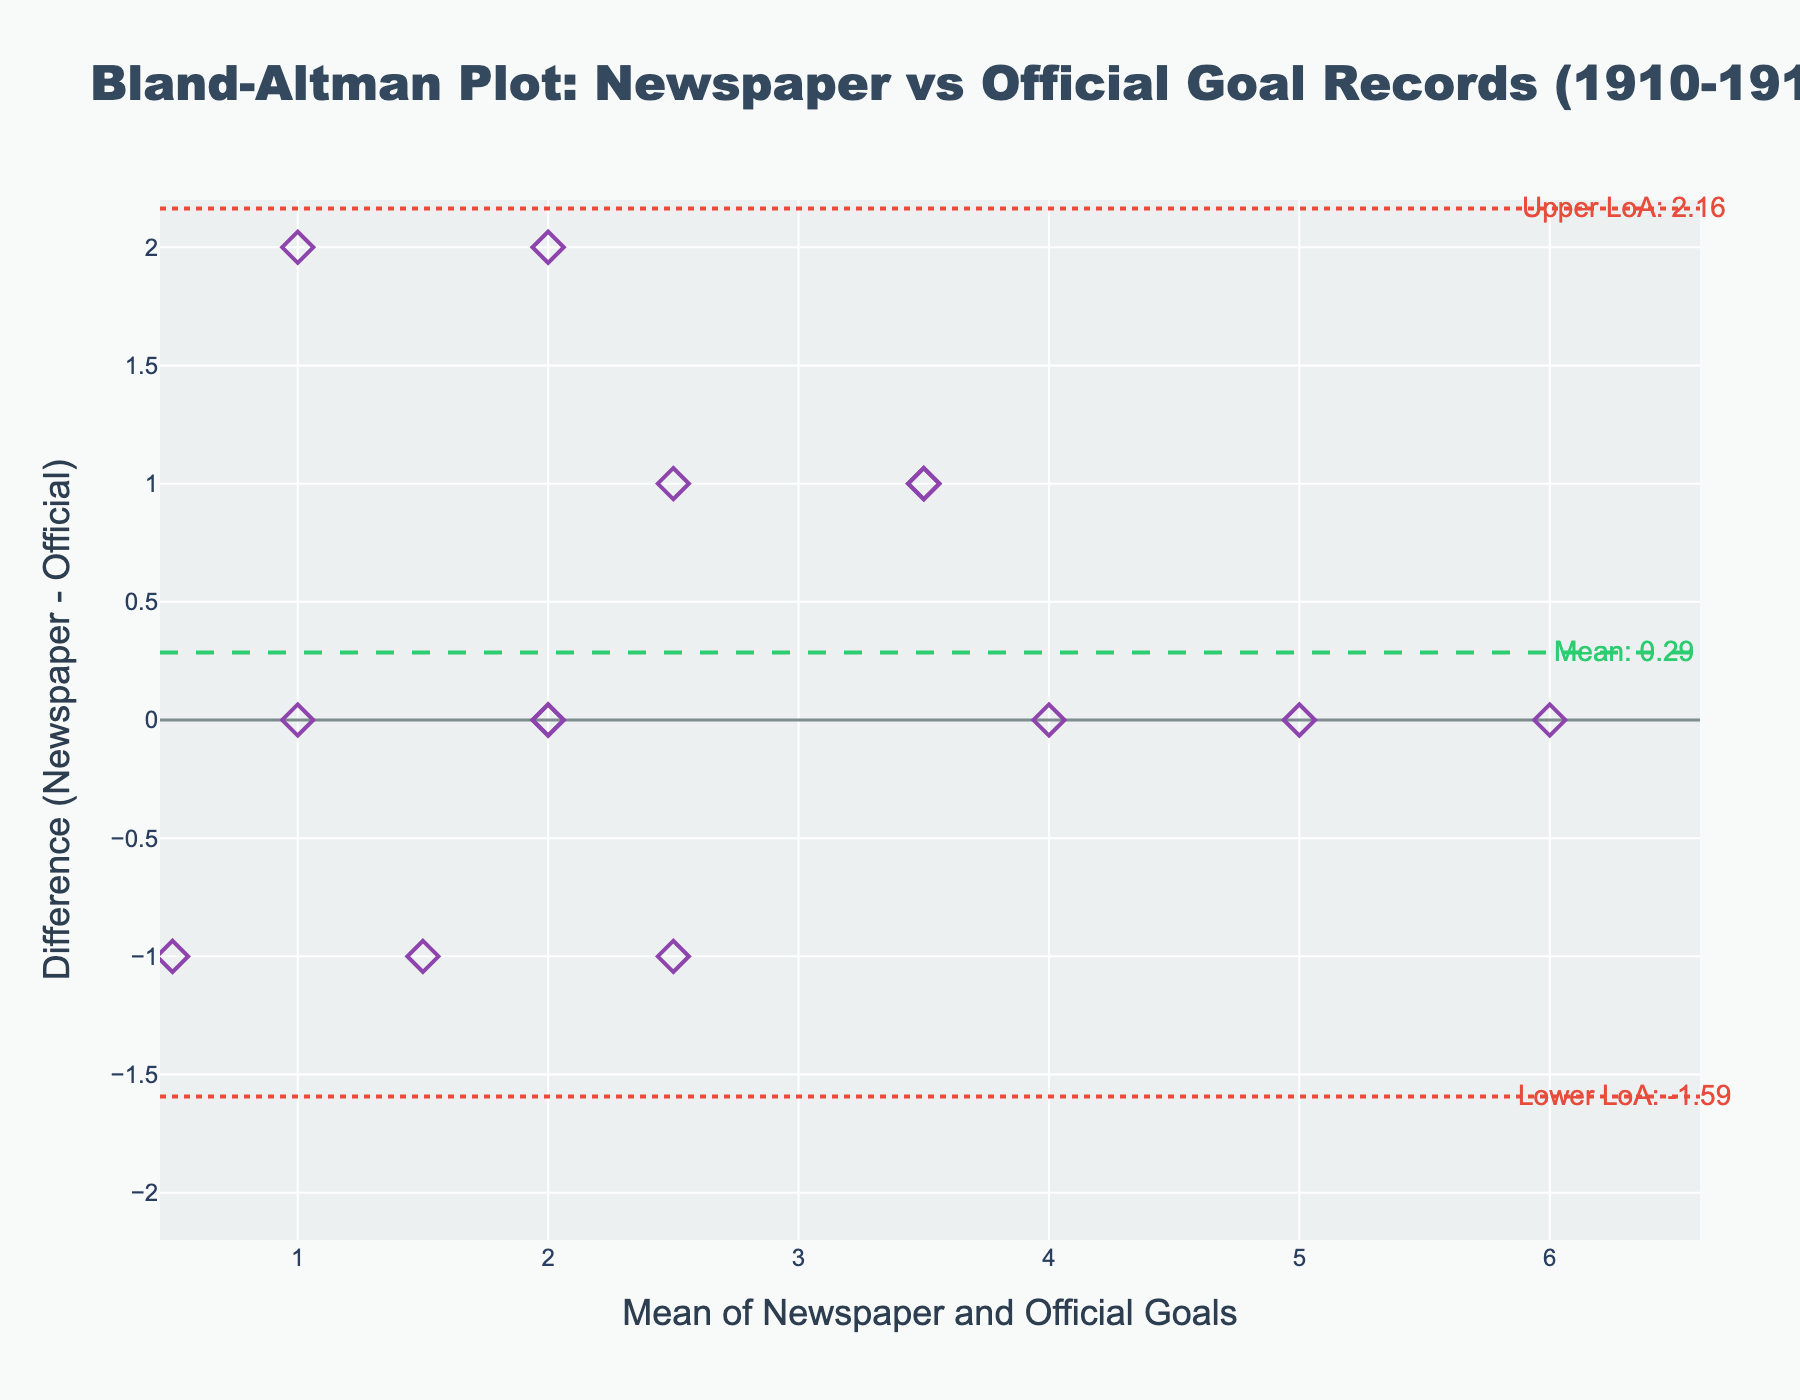what is the title of the plot? The title is usually found at the top of the plot and is meant to describe what the plot is about.
Answer: Bland-Altman Plot: Newspaper vs Official Goal Records (1910-1912) How many data points are shown in the plot? Counting the markers on the scatter plot gives the total number of data points.
Answer: 14 What do the x-axis and y-axis represent? The x-axis label indicates it represents the 'Mean of Newspaper and Official Goals' and the y-axis label indicates it represents the 'Difference (Newspaper - Official)'.
Answer: Mean of Newspaper and Official Goals and Difference (Newspaper - Official) What is the mean difference shown in the plot? The mean difference is displayed as a horizontal line with an annotation.
Answer: 0.36 What are the limits of agreement in the plot? The limits of agreement are displayed as two dotted horizontal lines with annotations showing their values.
Answer: -1.39 and 2.11 Which data point has the highest positive difference? By identifying the marker with the highest position on the y-axis and referring to the annotation or data points in the plot, we can find the answer.
Answer: 1911-01-07 (Difference = 2) Which data point has the highest negative difference? By identifying the marker with the lowest position on the y-axis and referring to the annotation or data points in the plot, we can find the answer.
Answer: 1911-04-29 (Difference = -1) Are there more positive differences or negative differences? Count the number of data points above and below the y=0 line.
Answer: Positive differences Is there a greater variability in the positive or negative differences? Compare the spread of data points above and below the mean difference line.
Answer: Positive differences Is there an overall tendency for newspapers to report higher or lower goals compared to official records? By examining whether more data points lie above or below the mean difference line, we can infer the overall tendency.
Answer: Higher goals 